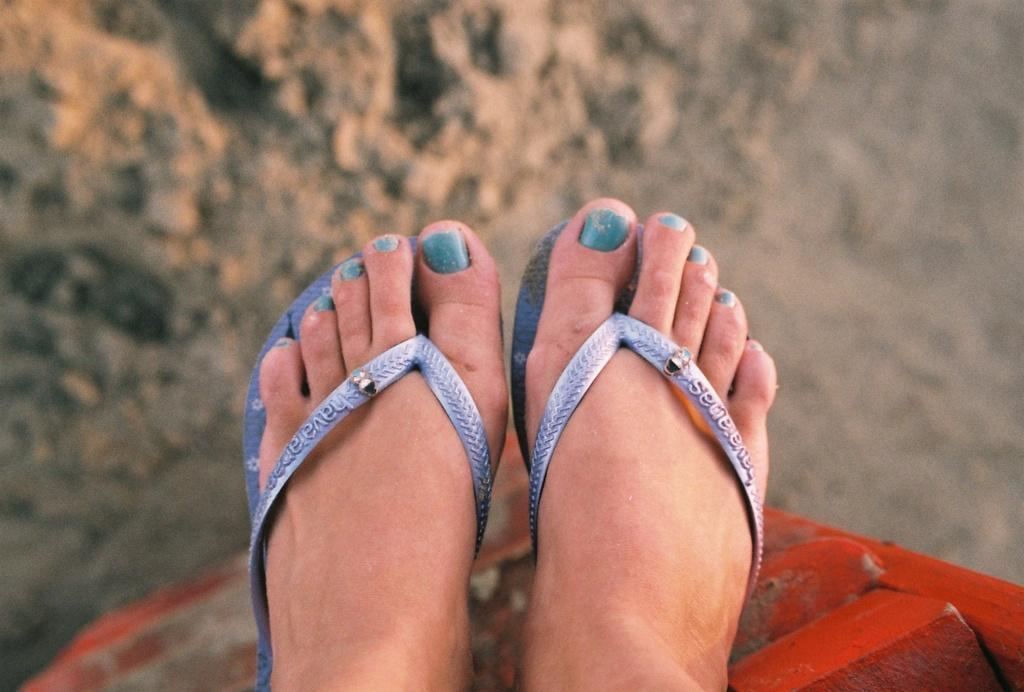Who or what is the main subject in the image? There is a person in the image. What part of the person's body can be seen? The person's legs are visible. What color are the shoes the person is wearing? The person's legs are wearing blue color footwear. What is the person's legs resting on? The legs are on a red color object. How would you describe the background of the image? The background of the image is blurred. What type of gold jewelry can be seen on the person's middle finger in the image? There is no gold jewelry or any jewelry visible on the person's middle finger in the image. 